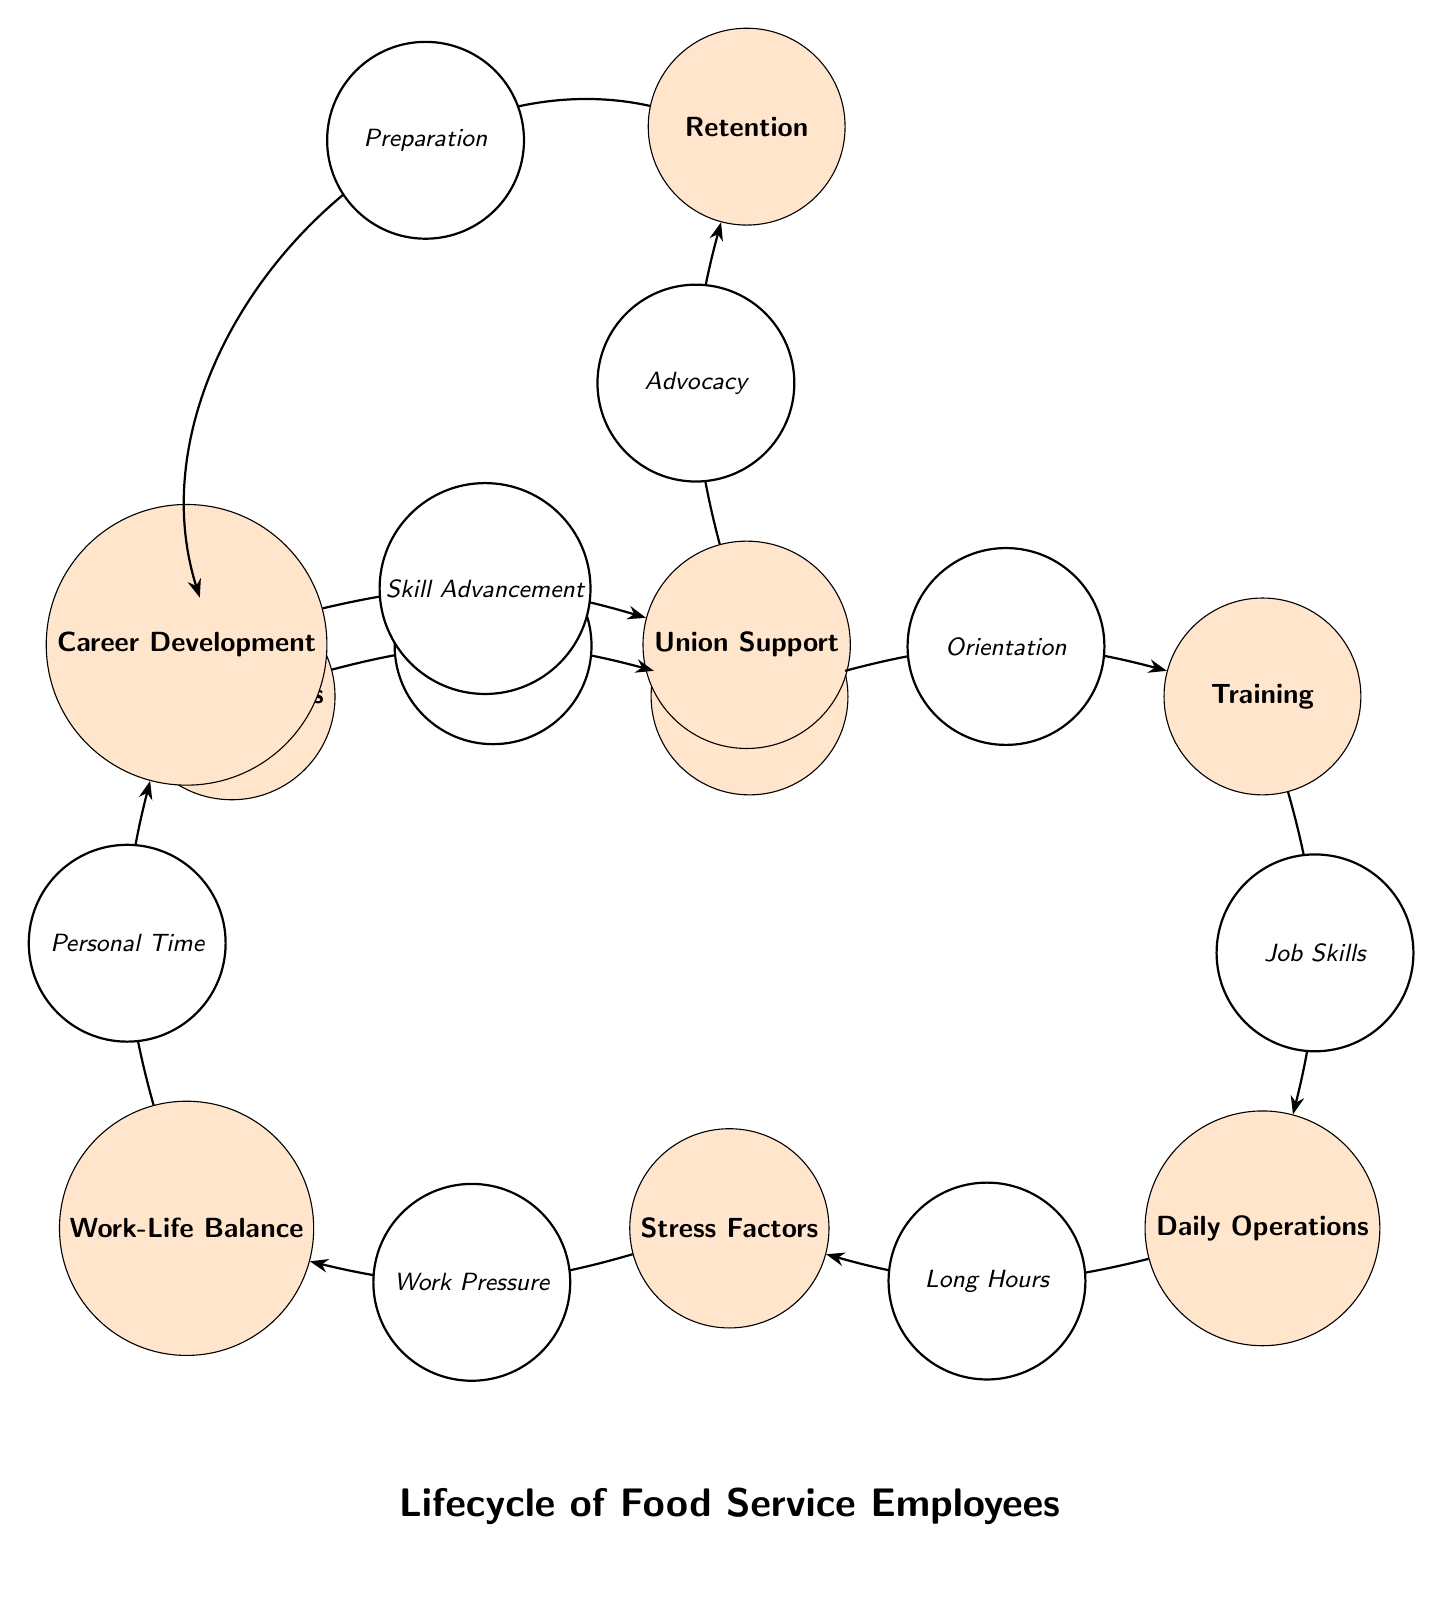What is the first step in the lifecycle? The diagram starts with the node labeled "Hiring Process," indicating that this is the first step in the lifecycle of food service employees.
Answer: Hiring Process How many total nodes are present in the diagram? Counting all the labeled nodes from "Hiring Process" to "Retention," there are a total of nine nodes depicted in the diagram.
Answer: 9 What node follows "Onboarding"? The node that directly follows "Onboarding" in the flow of the diagram is "Training," representing the next step after the onboarding process.
Answer: Training What is the last step in the lifecycle? The final node in the lifecycle as depicted in the diagram is "Retention," which indicates the end point of the employee journey in this food service lifecycle.
Answer: Retention Which node is connected to "Work-Life Balance"? The node that is directly connected to "Work-Life Balance" is "Stress Factors," as shown on the edge linking these two nodes.
Answer: Stress Factors How does "Union Support" connect to "Career Development"? "Union Support" is linked to "Career Development" through the flow of the diagram, following "Skill Advancement," which highlights the role of unions in career progression.
Answer: Through Skill Advancement What does "Daily Operations" lead to? The "Daily Operations" node leads to "Stress Factors," indicating that daily tasks can contribute to stress in the workplace.
Answer: Stress Factors What role does "Advocacy" play in the lifecycle? "Advocacy," located after "Union Support," plays a critical role as it connects to "Retention," highlighting how advocacy efforts can help retain employees.
Answer: Retention How is "Preparation" connected to "Hiring Process"? "Preparation" is connected to "Hiring Process" with a bend in the edge, reflecting a cyclical nature where preparation is part of the ongoing process of hiring new staff.
Answer: Through retention 